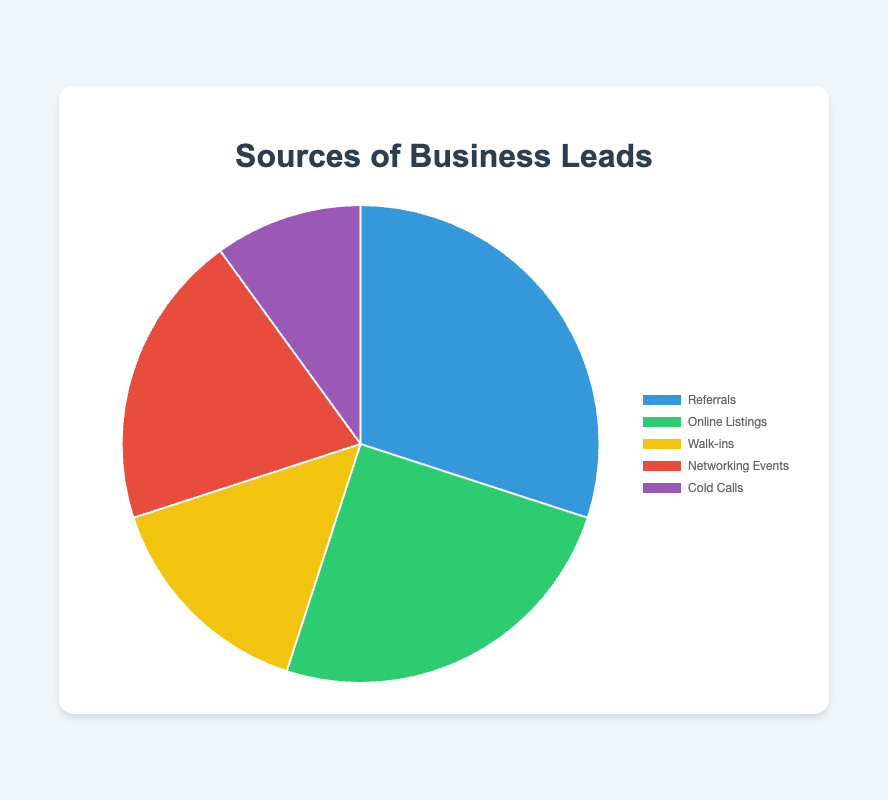What is the most common source of business leads? The pie chart shows different segments with their associated percentages. The largest segment represents the most common source. Referrals have the highest percentage at 30%.
Answer: Referrals Which source of business leads contributes the least? The pie chart displays different slices, each representing a source along with the percentage. The smallest slice represents Cold Calls at 10%.
Answer: Cold Calls How much more significant are Referrals compared to Cold Calls? To find this, we subtract the percentage of Cold Calls from Referrals. Referrals are 30% and Cold Calls are 10%, so 30% - 10% = 20%.
Answer: 20% What percentage of business leads are generated from Online Listings and Networking Events combined? We need to add the percentages of Online Listings and Networking Events. Online Listings contribute 25% and Networking Events contribute 20%, so 25% + 20% = 45%.
Answer: 45% Is the percentage of Walk-ins higher or lower than that of Networking Events? By comparing the two percentages: Walk-ins are at 15% and Networking Events are at 20%. Walk-ins are lower than Networking Events.
Answer: Lower If you combine the sources with the two smallest percentages, what proportion of business leads do they constitute? The two smallest percentages are from Cold Calls (10%) and Walk-ins (15%). Adding them together gives 10% + 15% = 25%.
Answer: 25% What visual attribute color represents Networking Events? By looking at the pie chart with labeled colors, Networking Events are often visually distinguished by a specific color. Here, it is red.
Answer: Red 